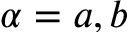Convert formula to latex. <formula><loc_0><loc_0><loc_500><loc_500>\alpha = a , b</formula> 